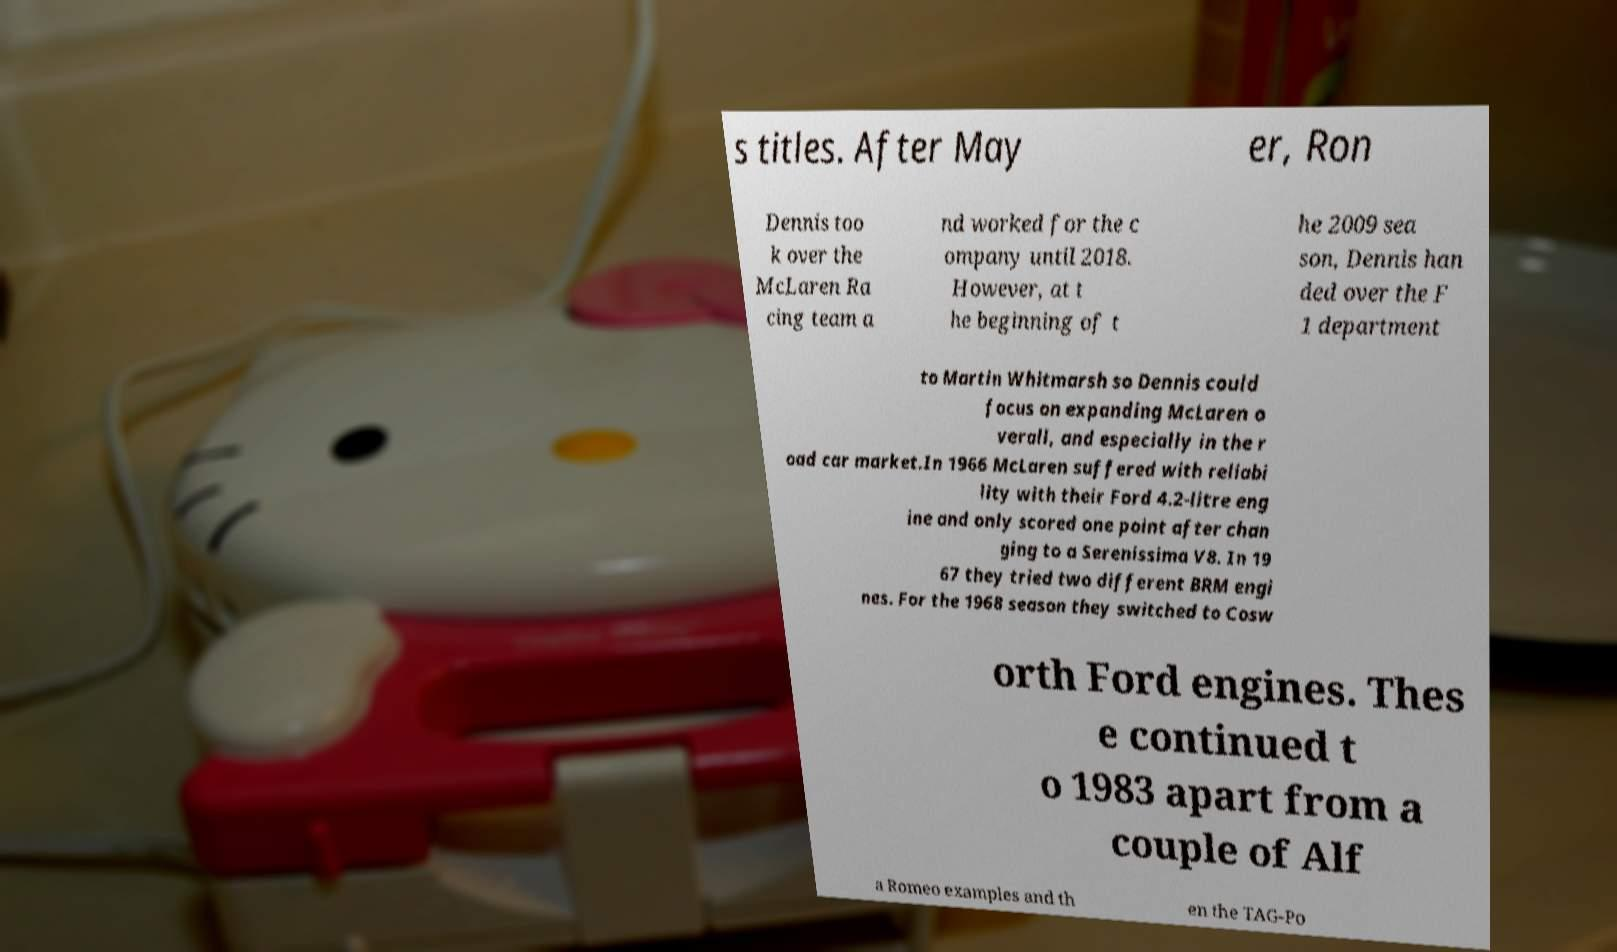Can you accurately transcribe the text from the provided image for me? s titles. After May er, Ron Dennis too k over the McLaren Ra cing team a nd worked for the c ompany until 2018. However, at t he beginning of t he 2009 sea son, Dennis han ded over the F 1 department to Martin Whitmarsh so Dennis could focus on expanding McLaren o verall, and especially in the r oad car market.In 1966 McLaren suffered with reliabi lity with their Ford 4.2-litre eng ine and only scored one point after chan ging to a Serenissima V8. In 19 67 they tried two different BRM engi nes. For the 1968 season they switched to Cosw orth Ford engines. Thes e continued t o 1983 apart from a couple of Alf a Romeo examples and th en the TAG-Po 